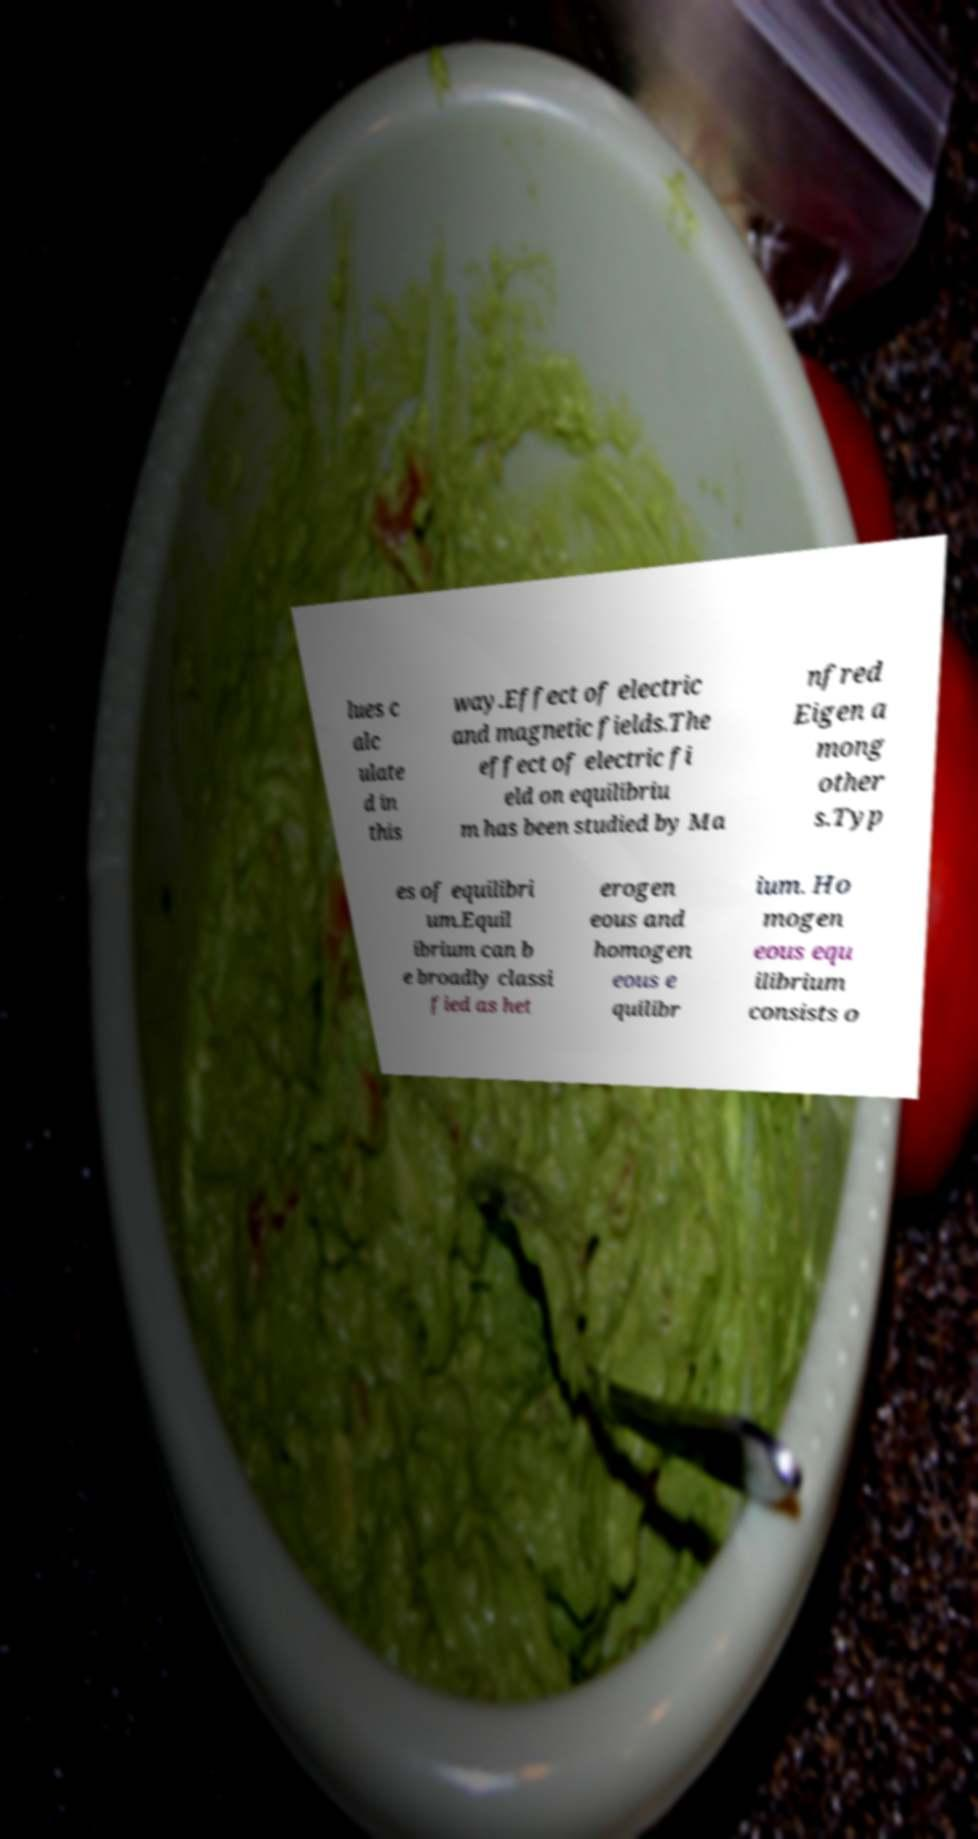Can you accurately transcribe the text from the provided image for me? lues c alc ulate d in this way.Effect of electric and magnetic fields.The effect of electric fi eld on equilibriu m has been studied by Ma nfred Eigen a mong other s.Typ es of equilibri um.Equil ibrium can b e broadly classi fied as het erogen eous and homogen eous e quilibr ium. Ho mogen eous equ ilibrium consists o 